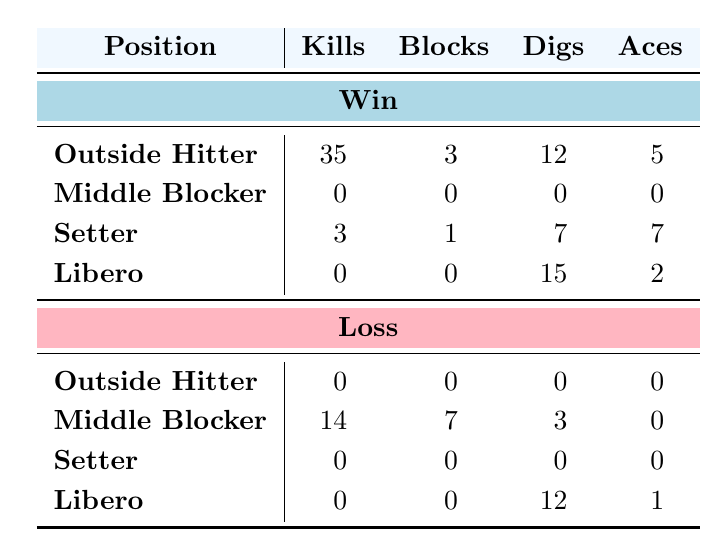What is the total number of Kills for Outside Hitters in wins? There are two Outside Hitters in the win category: Alice Johnson with 15 Kills and Emma Clark with 20 Kills. To find the total, we sum these values: 15 + 20 = 35.
Answer: 35 How many Blocks did Middle Blockers achieve in losses? There is one Middle Blocker in the loss category: Brian Smith with 4 Blocks and Grace Walker with 7 Blocks. Summing these gives us: 4 + 7 = 11 Blocks.
Answer: 11 Did any Setter achieve any Kills in a loss? In the loss category, there are two Setters: Cara Nelson and Frank Adams. Both recorded 0 Kills, confirming that no Setter achieved Kills in this category.
Answer: No Which position had the highest total number of Service Aces in wins? The total Service Aces for each position in wins is as follows: Outside Hitter (5), Middle Blocker (0), Setter (7), and Libero (2). The highest total is for the Setter with 7 Service Aces.
Answer: Setter What is the combined total of Digs for all positions in losses? The total Digs in losses are from: Middle Blocker (3), Libero (12), and from the Outside Hitters and Setters, both having 0 Digs. Adding these gives: 3 + 12 + 0 + 0 = 15.
Answer: 15 Was there any player from the Libero position who contributed Kills in a win? In the win section for Liberos, Henry King is listed with 0 Kills, indicating that no player in the Libero position contributed any Kills in the win category.
Answer: No How many more Digs did Liberos achieve in wins compared to losses? In wins, Liberos recorded 15 Digs (Henry King). In losses, Liberos had 12 Digs (David Lee). The difference is 15 - 12 = 3 more Digs in wins compared to losses.
Answer: 3 Calculate the average number of Blocks for Outside Hitters across both outcomes. The two Outside Hitters in wins had a total of 3 Blocks (Alice Johnson 2 + Emma Clark 1) and 0 Blocks in losses, which is 3 Blocks total across 2 instances. Average = 3/2 = 1.5 Blocks.
Answer: 1.5 